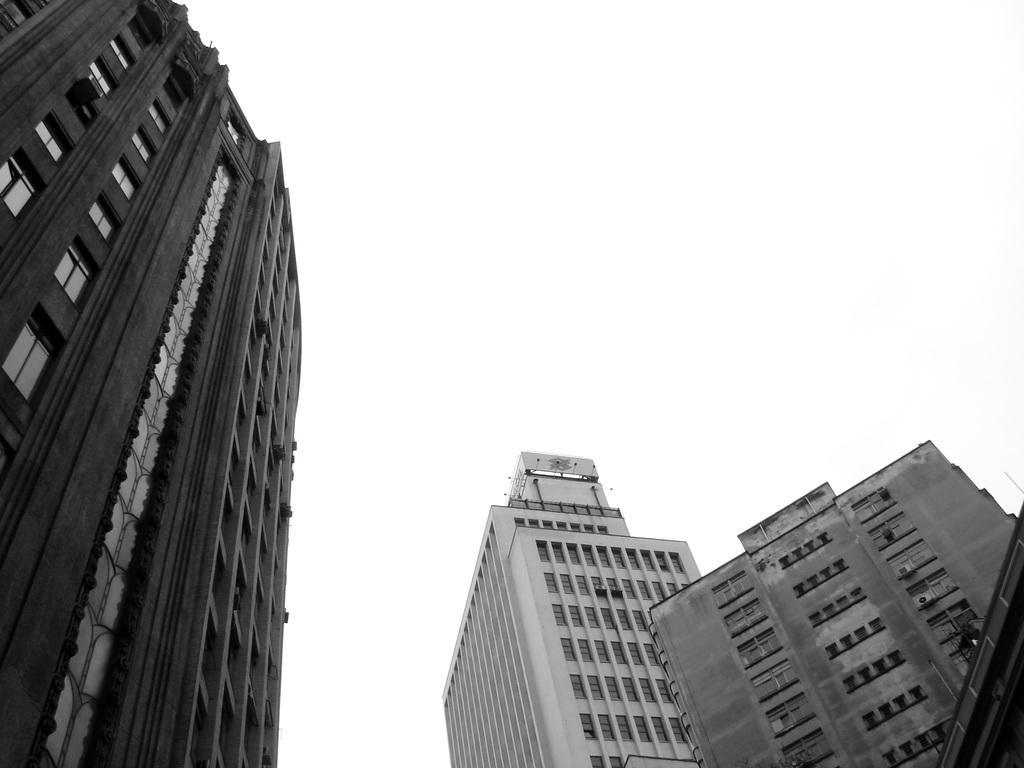Please provide a concise description of this image. In this picture there are some building in the front. Behind there is a white background. 